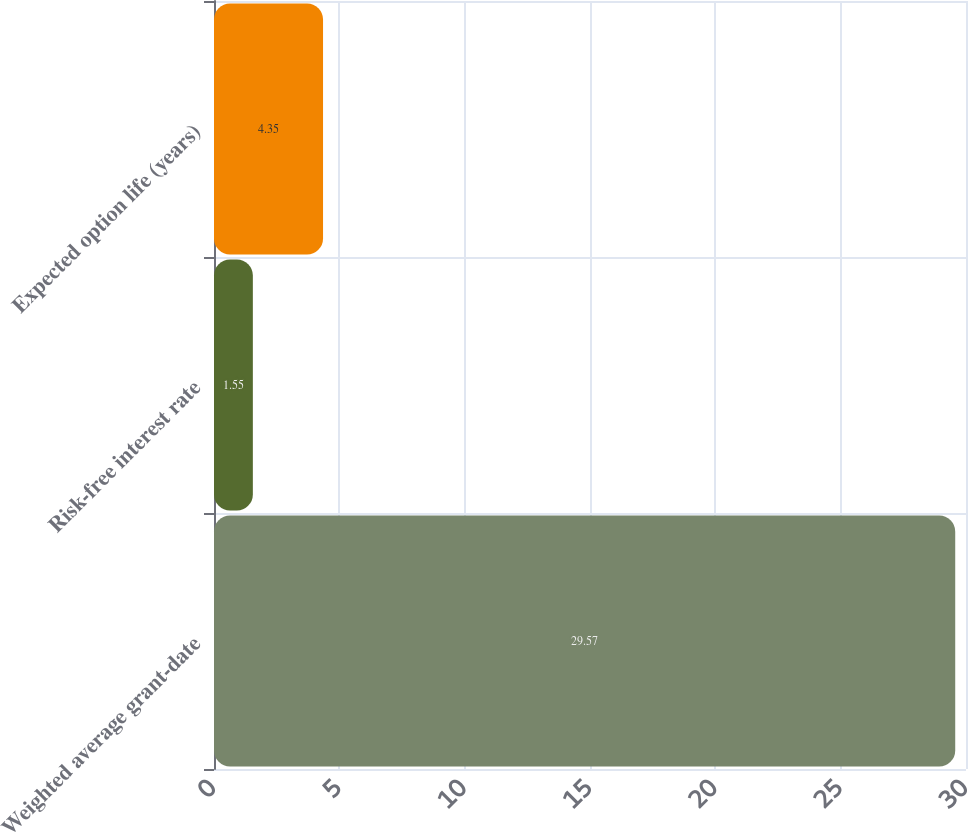Convert chart. <chart><loc_0><loc_0><loc_500><loc_500><bar_chart><fcel>Weighted average grant-date<fcel>Risk-free interest rate<fcel>Expected option life (years)<nl><fcel>29.57<fcel>1.55<fcel>4.35<nl></chart> 